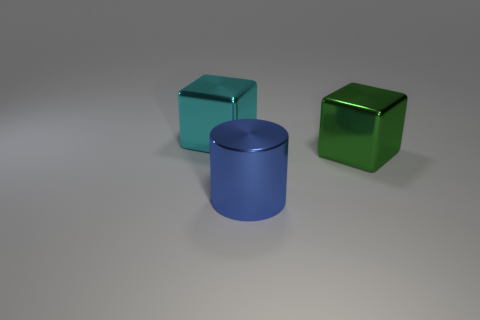Add 2 small brown shiny cylinders. How many objects exist? 5 Subtract all blocks. How many objects are left? 1 Subtract 0 blue balls. How many objects are left? 3 Subtract all big blue rubber objects. Subtract all metallic objects. How many objects are left? 0 Add 3 green metallic objects. How many green metallic objects are left? 4 Add 1 small cyan rubber cylinders. How many small cyan rubber cylinders exist? 1 